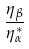Convert formula to latex. <formula><loc_0><loc_0><loc_500><loc_500>\frac { \eta _ { \beta } } { \eta _ { \alpha } ^ { * } }</formula> 